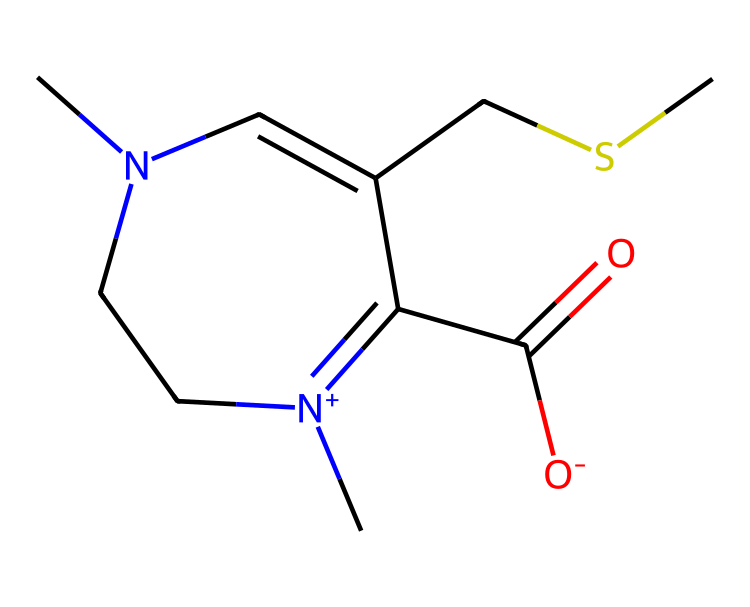What is the name of this compound? The SMILES representation indicates that the compound is ergothioneine, which is a known antioxidant present in some mushrooms.
Answer: ergothioneine How many nitrogen atoms are present in the structure? By analyzing the SMILES, there are two nitrogen atoms indicated by the "[N+]" and "[N]" notations, which denote positively charged and neutral nitrogen, respectively.
Answer: two What functional groups are present in ergothioneine? The structure reveals a carboxylic acid group (-COOH) as indicated by "C(=O)[O-]", and a thiol group (-SH) as suggested by "CSC".
Answer: carboxylic acid and thiol What is the oxidation state of the sulfur atom? The sulfur atom is bonded to a carbon and appears in a thioether linkage here, suggesting it is in a relatively low oxidation state, specifically -2.
Answer: -2 How many total carbon atoms are in ergothioneine? Counting the 'C' notations in the SMILES, there are seven carbon atoms present in the structure.
Answer: seven What type of compound is ergothioneine classified as? Based on its molecular structure and the presence of sulfur and nitrogen, ergothioneine is classified as an organosulfur compound.
Answer: organosulfur Does ergothioneine have any chiral centers? The presence of two distinct nitrogen-containing rings and the arrangement of its carbon skeleton indicates that ergothioneine does have chiral centers, specifically at two of its carbon atoms.
Answer: yes 